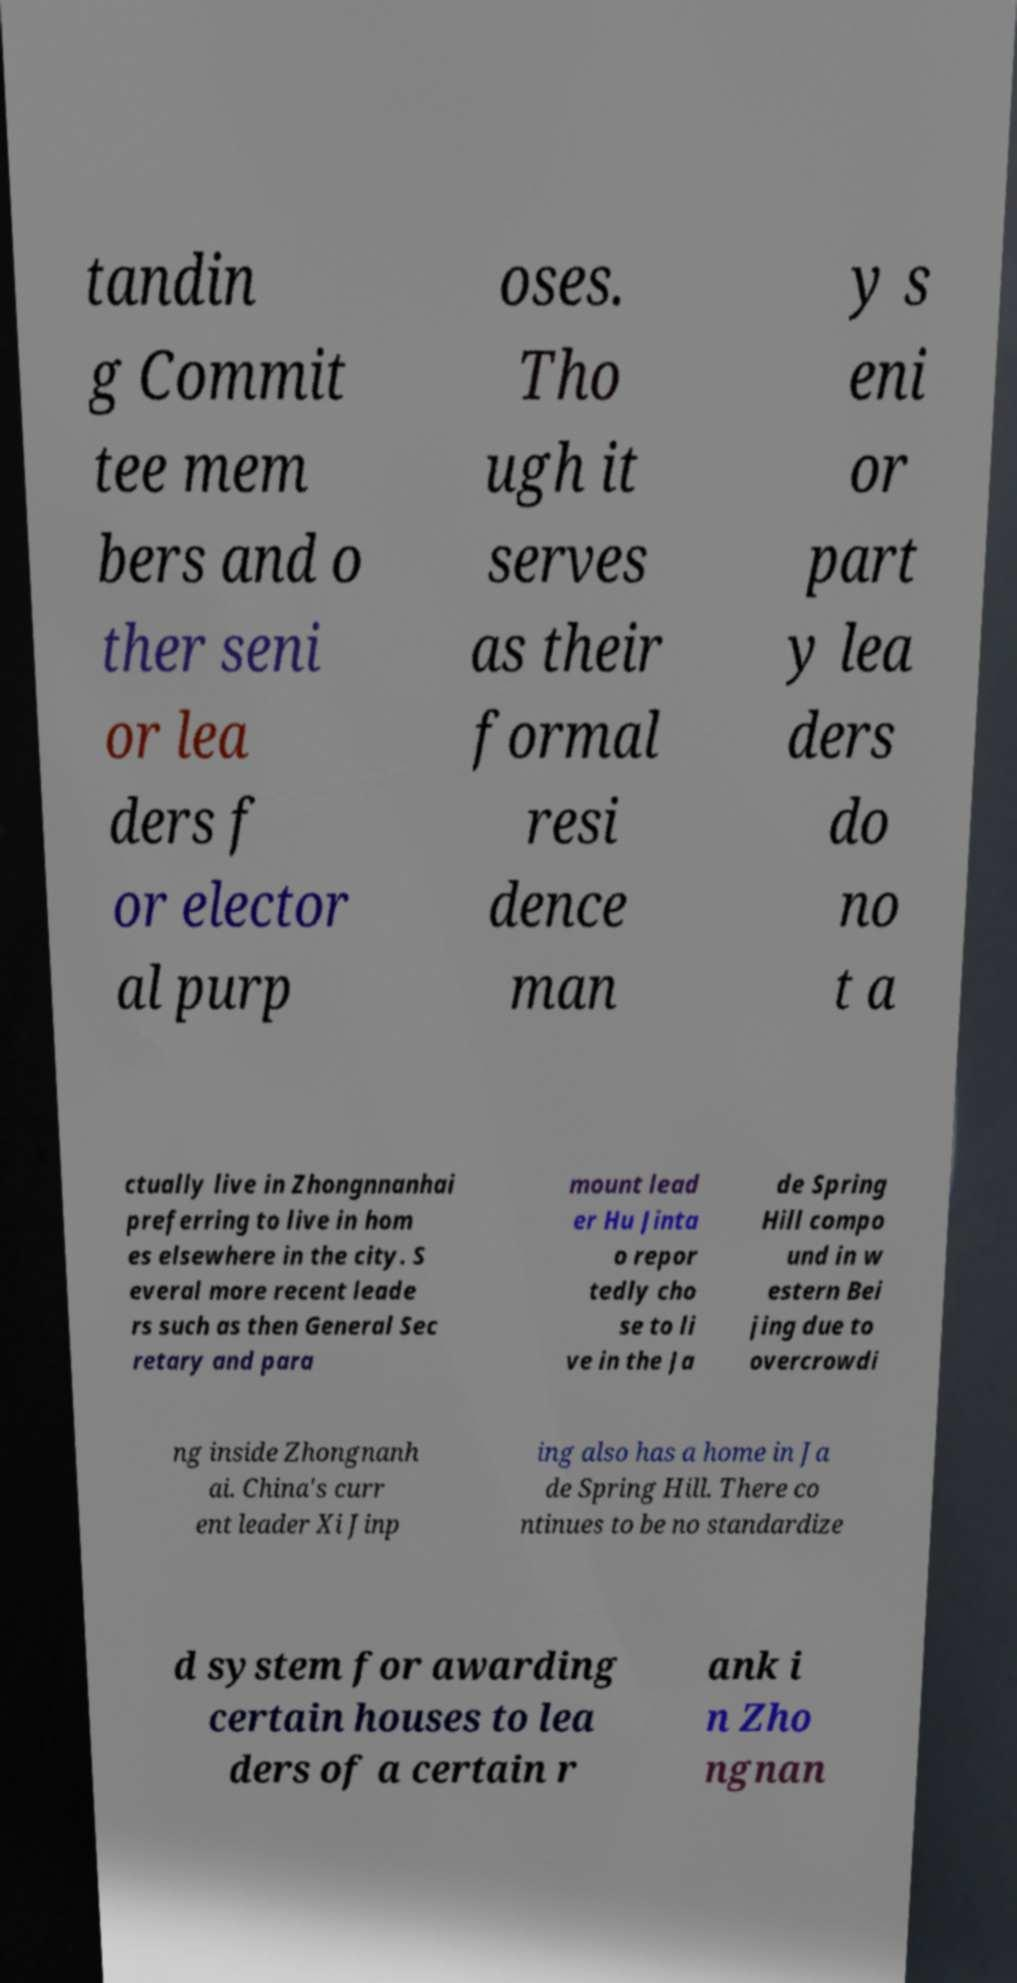I need the written content from this picture converted into text. Can you do that? tandin g Commit tee mem bers and o ther seni or lea ders f or elector al purp oses. Tho ugh it serves as their formal resi dence man y s eni or part y lea ders do no t a ctually live in Zhongnnanhai preferring to live in hom es elsewhere in the city. S everal more recent leade rs such as then General Sec retary and para mount lead er Hu Jinta o repor tedly cho se to li ve in the Ja de Spring Hill compo und in w estern Bei jing due to overcrowdi ng inside Zhongnanh ai. China's curr ent leader Xi Jinp ing also has a home in Ja de Spring Hill. There co ntinues to be no standardize d system for awarding certain houses to lea ders of a certain r ank i n Zho ngnan 